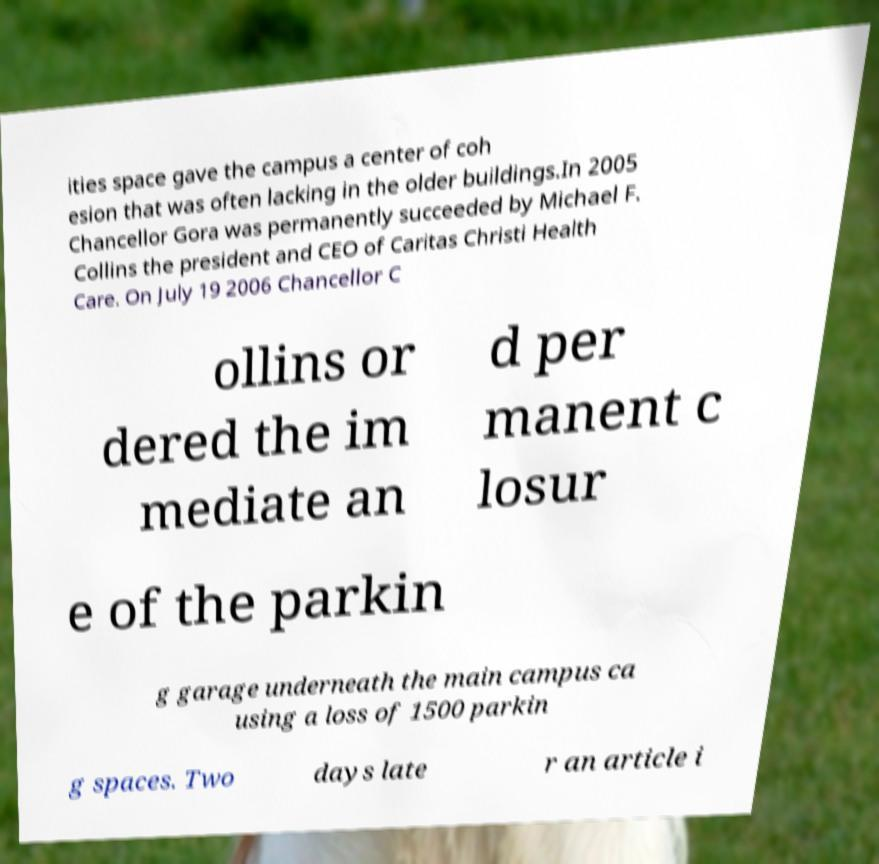Can you accurately transcribe the text from the provided image for me? ities space gave the campus a center of coh esion that was often lacking in the older buildings.In 2005 Chancellor Gora was permanently succeeded by Michael F. Collins the president and CEO of Caritas Christi Health Care. On July 19 2006 Chancellor C ollins or dered the im mediate an d per manent c losur e of the parkin g garage underneath the main campus ca using a loss of 1500 parkin g spaces. Two days late r an article i 